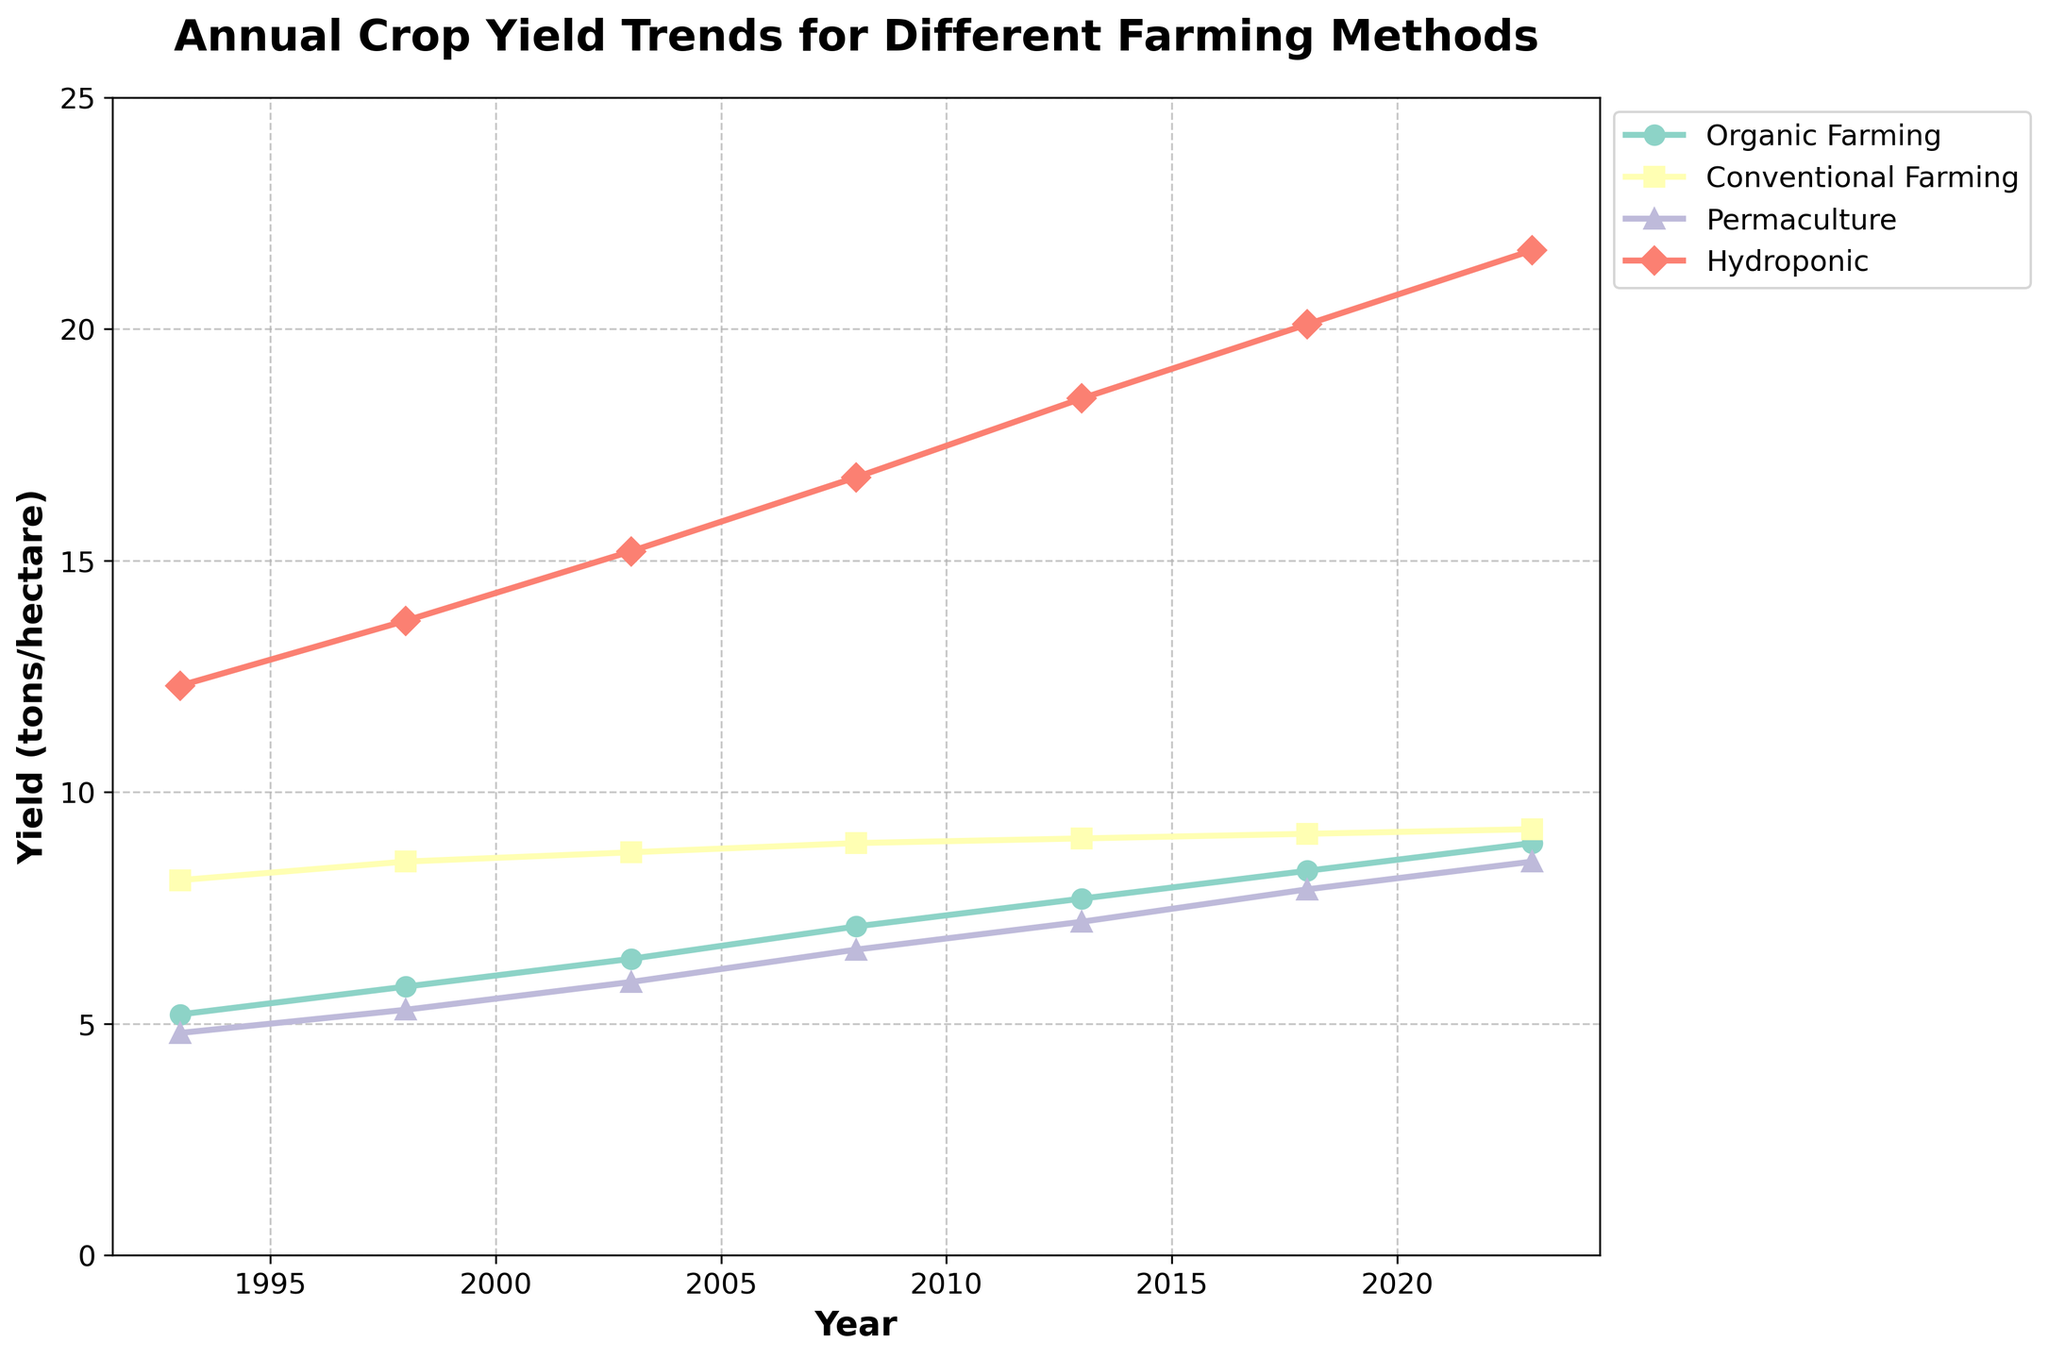What is the yield trend for Hydroponic farming over the last 30 years? The plot shows an upward trajectory for Hydroponic farming yields each year. Starting from 12.3 tons/hectare in 1993, it reaches 21.7 tons/hectare in 2023. This indicates a consistent increase in yield through the years.
Answer: Increased consistently Which farming method had the highest yield in 2023? Refer to the visual representation of the lines in the plot. Hydroponic farming has the highest point in 2023 at 21.7 tons/hectare, surpassing the other methods.
Answer: Hydroponic farming By how much did Permaculture farming yield increase from 1993 to 2023? Start by noting the yield for Permaculture farming in 1993 and 2023. Subtract the former from the latter. (8.5 - 4.8 = 3.7 tons/hectare)
Answer: 3.7 tons/hectare Which farming method shows the smallest change in yield from 1993 to 2023? Look at the yield changes for each method in the plot. Conventional Farming varies the least, starting from 8.1 in 1993 and rising to just 9.2 in 2023.
Answer: Conventional Farming What is the average organic farming yield over the 30-year span? List the organic farming yields and calculate their average: (5.2 + 5.8 + 6.4 + 7.1 + 7.7 + 8.3 + 8.9). The sum is 49.4, and there are 7 data points, so the average is 49.4/7 = 7.06 tons/hectare.
Answer: 7.06 tons/hectare How does the yield of Permaculture farming in 2013 compare to Organic farming in the same year? Look at the plot for both yields in 2013. Permaculture yield is 7.2, and Organic farming yield is 7.7. Thus, Organic farming is higher.
Answer: Organic farming is higher What is the trend for Conventional farming between 1993 and 2023? Observe the line representing Conventional farming in the plot. It starts at 8.1 tons/hectare and rises slightly to 9.2 tons/hectare, indicating a minor but gradual increase.
Answer: Slightly increased Which two farming methods had the closest yields in 1993? Compare the starting points for all methods. Organic and Permaculture yield are 5.2 and 4.8 tons/hectare, respectively, which are the closest.
Answer: Organic and Permaculture What visual attributes distinguish Hydroponic farming on the plot? Hydroponic farming is identified by a unique color and marker shape (red color with a diamond marker) that clearly differentiate it from other farming methods.
Answer: Red color and diamond marker Compare the slope of the yield curve for Hydroponic farming to that of Organic farming. Which has a steeper slope? By examining both lines on the plot, Hydroponic farming shows a steeper increase in yield, reflected by a sharper rise, compared to Organic farming’s more gradual slope.
Answer: Hydroponic farming has a steeper slope 